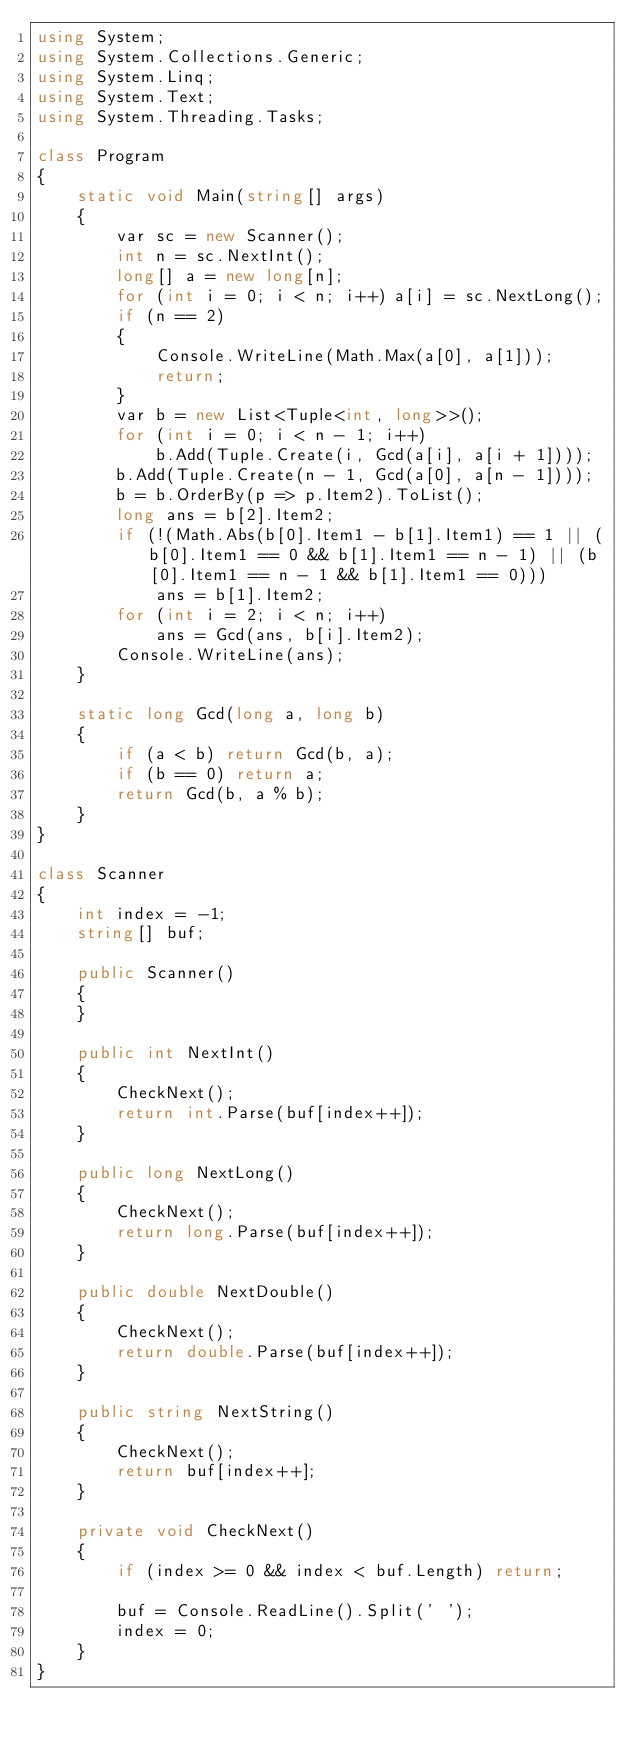Convert code to text. <code><loc_0><loc_0><loc_500><loc_500><_C#_>using System;
using System.Collections.Generic;
using System.Linq;
using System.Text;
using System.Threading.Tasks;

class Program
{
    static void Main(string[] args)
    {
        var sc = new Scanner();
        int n = sc.NextInt();
        long[] a = new long[n];
        for (int i = 0; i < n; i++) a[i] = sc.NextLong();
        if (n == 2)
        {
            Console.WriteLine(Math.Max(a[0], a[1]));
            return;
        }
        var b = new List<Tuple<int, long>>();
        for (int i = 0; i < n - 1; i++)
            b.Add(Tuple.Create(i, Gcd(a[i], a[i + 1])));
        b.Add(Tuple.Create(n - 1, Gcd(a[0], a[n - 1])));
        b = b.OrderBy(p => p.Item2).ToList();
        long ans = b[2].Item2;
        if (!(Math.Abs(b[0].Item1 - b[1].Item1) == 1 || (b[0].Item1 == 0 && b[1].Item1 == n - 1) || (b[0].Item1 == n - 1 && b[1].Item1 == 0)))
            ans = b[1].Item2;
        for (int i = 2; i < n; i++)
            ans = Gcd(ans, b[i].Item2);
        Console.WriteLine(ans);
    }

    static long Gcd(long a, long b)
    {
        if (a < b) return Gcd(b, a);
        if (b == 0) return a;
        return Gcd(b, a % b);
    }
}

class Scanner
{
    int index = -1;
    string[] buf;

    public Scanner()
    {
    }

    public int NextInt()
    {
        CheckNext();
        return int.Parse(buf[index++]);
    }

    public long NextLong()
    {
        CheckNext();
        return long.Parse(buf[index++]);
    }

    public double NextDouble()
    {
        CheckNext();
        return double.Parse(buf[index++]);
    }

    public string NextString()
    {
        CheckNext();
        return buf[index++];
    }

    private void CheckNext()
    {
        if (index >= 0 && index < buf.Length) return;

        buf = Console.ReadLine().Split(' ');
        index = 0;
    }
}
</code> 